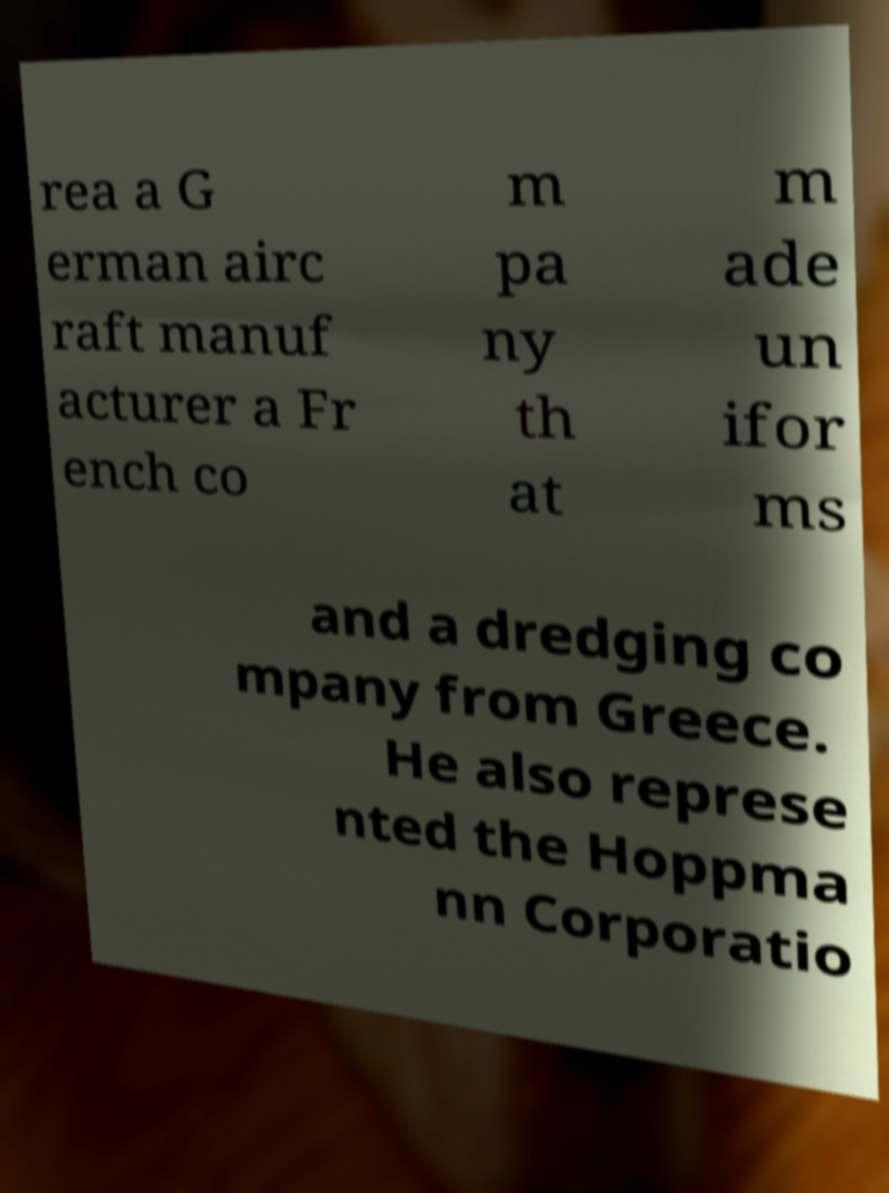For documentation purposes, I need the text within this image transcribed. Could you provide that? rea a G erman airc raft manuf acturer a Fr ench co m pa ny th at m ade un ifor ms and a dredging co mpany from Greece. He also represe nted the Hoppma nn Corporatio 